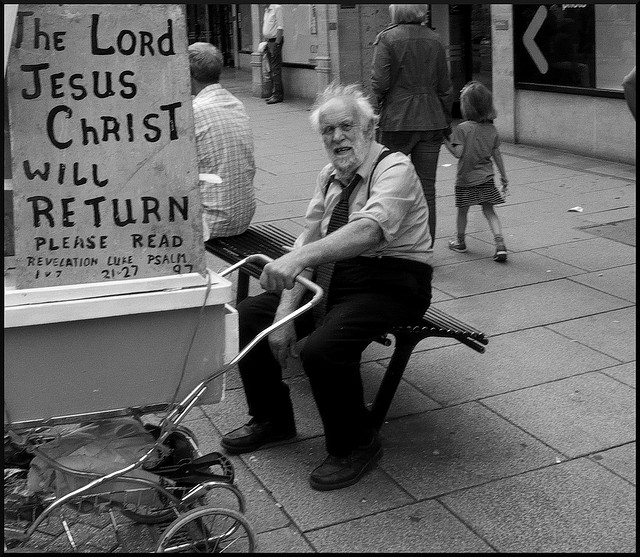<image>What is the function of the business behind the girl? The function of the business behind the girl is not sure. It could be a store, cell phone shop, post office, retail shop, or bank. What knee is he leaning on? It's ambiguous what knee he is leaning on. It can be seen as right or left. What knee is he leaning on? It is unanswerable what knee he is leaning on. What is the function of the business behind the girl? I am not sure what is the function of the business behind the girl. It can be a store, cell phone shop, post office, retail, or a bank. 